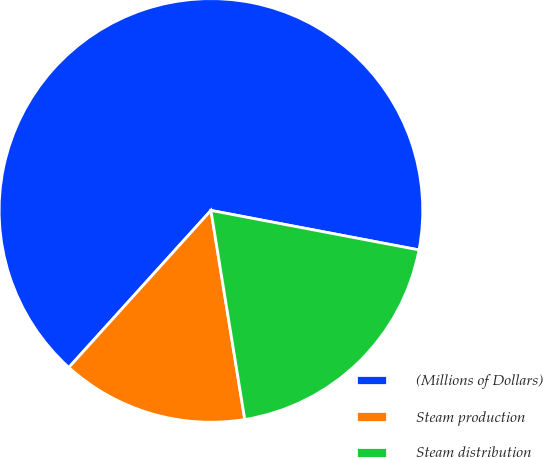Convert chart. <chart><loc_0><loc_0><loc_500><loc_500><pie_chart><fcel>(Millions of Dollars)<fcel>Steam production<fcel>Steam distribution<nl><fcel>66.28%<fcel>14.26%<fcel>19.46%<nl></chart> 